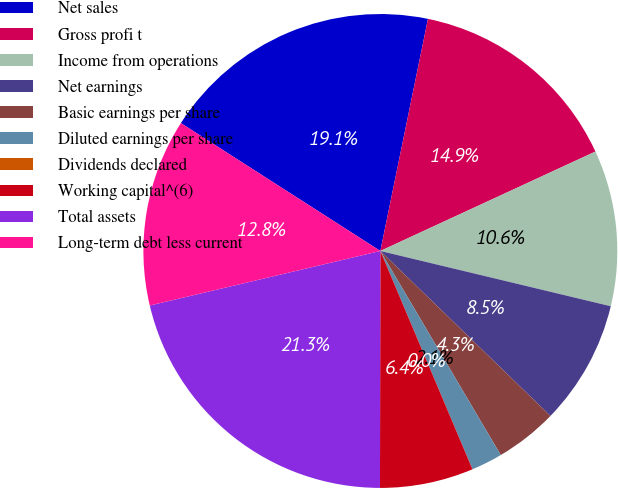<chart> <loc_0><loc_0><loc_500><loc_500><pie_chart><fcel>Net sales<fcel>Gross profi t<fcel>Income from operations<fcel>Net earnings<fcel>Basic earnings per share<fcel>Diluted earnings per share<fcel>Dividends declared<fcel>Working capital^(6)<fcel>Total assets<fcel>Long-term debt less current<nl><fcel>19.15%<fcel>14.89%<fcel>10.64%<fcel>8.51%<fcel>4.26%<fcel>2.13%<fcel>0.0%<fcel>6.38%<fcel>21.28%<fcel>12.77%<nl></chart> 